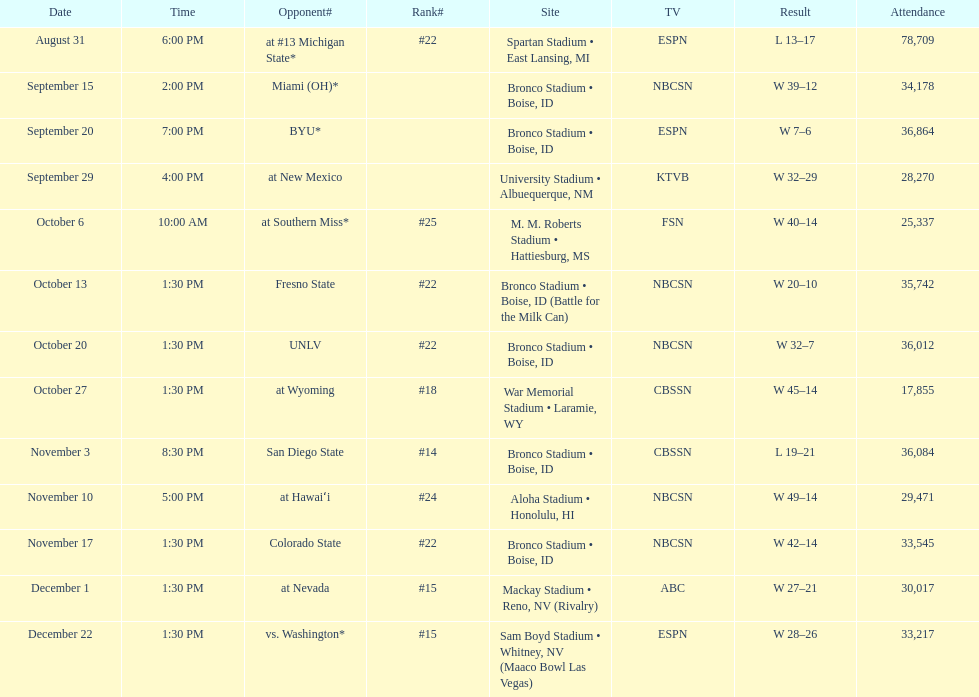What is the score difference for the game against michigan state? 4. 